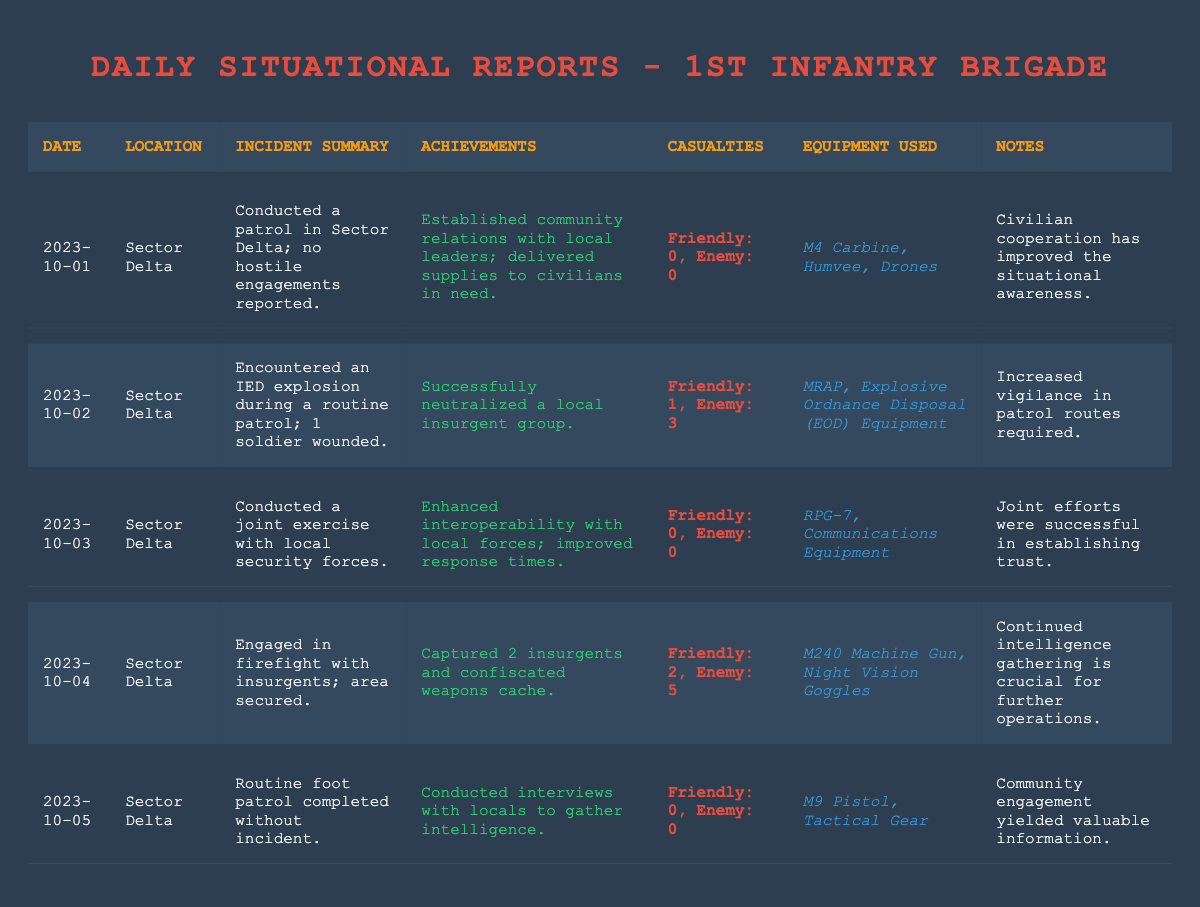What was the incident summary on October 1, 2023? The incident summary for October 1, 2023, states that a patrol was conducted in Sector Delta with no hostile engagements reported.
Answer: Conducted a patrol in Sector Delta; no hostile engagements reported How many casualties were reported on October 2, 2023? On October 2, 2023, the report indicates that there was 1 friendly casualty and 3 enemy casualties.
Answer: 1 friendly, 3 enemy What equipment was used during the incident on October 4, 2023? For the incident on October 4, 2023, the equipment used included an M240 Machine Gun and Night Vision Goggles.
Answer: M240 Machine Gun, Night Vision Goggles Was there any reported incident on October 5, 2023? The report for October 5, 2023, indicates that a routine foot patrol was completed without any incidents.
Answer: No incidents reported How many enemy casualties were recorded over the days from October 1 to October 5, 2023? The enemy casualties reported are 0 (Oct 1) + 3 (Oct 2) + 0 (Oct 3) + 5 (Oct 4) + 0 (Oct 5) = 8. Therefore, there were 8 enemy casualties in total.
Answer: 8 enemy casualties What was the achievement of the unit on October 3, 2023? The achievement on October 3, 2023, was enhanced interoperability with local forces and improved response times from conducting a joint exercise.
Answer: Enhanced interoperability with local forces; improved response times Which date had the highest number of friendly casualties? The highest number of friendly casualties occurred on October 4, 2023, with 2 friendly casualties reported.
Answer: October 4, 2023 Did the unit experience any hostile engagements on October 1, 2023? According to the report, there were no hostile engagements reported on October 1, 2023.
Answer: No, there were no hostile engagements What were the benefits of community relations as mentioned on October 1, 2023? The benefits of community relations included the establishment of relations with local leaders and delivery of supplies to civilians, improving situational awareness.
Answer: Improved situational awareness and community relations Based on the incident reports, what can be inferred about the unit’s operations in early October 2023? The unit's operations show a mix of both hostile and non-hostile engagements, emphasizing community engagement along with military operations to enhance security and intelligence.
Answer: Mix of hostile and non-hostile engagements; focus on community engagement 